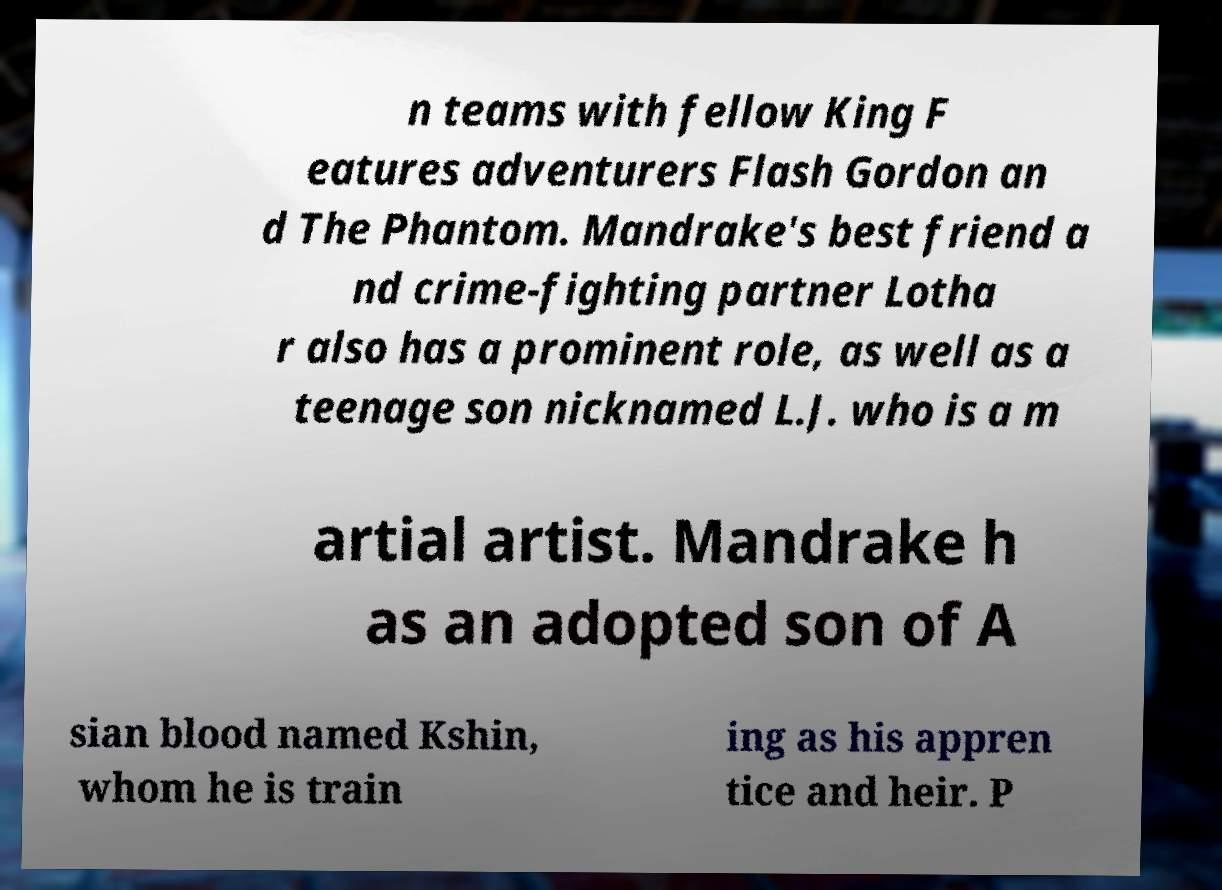Please identify and transcribe the text found in this image. n teams with fellow King F eatures adventurers Flash Gordon an d The Phantom. Mandrake's best friend a nd crime-fighting partner Lotha r also has a prominent role, as well as a teenage son nicknamed L.J. who is a m artial artist. Mandrake h as an adopted son of A sian blood named Kshin, whom he is train ing as his appren tice and heir. P 